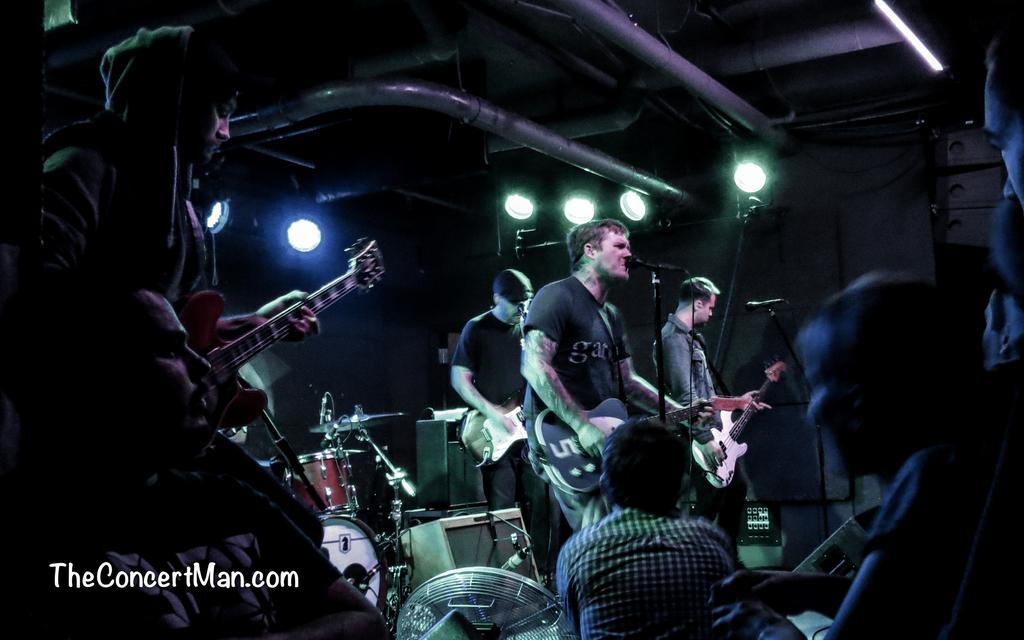What is happening in the image involving a group of people? There is a group of people in the image, and they are playing musical instruments. Where are the people located in the image? The people are standing on a stage in the image. What can be seen in the background of the image? There are lights and rods visible in the background of the image. What color is the list that the people are kicking in the image? There is no list present in the image, and the people are not kicking anything. 